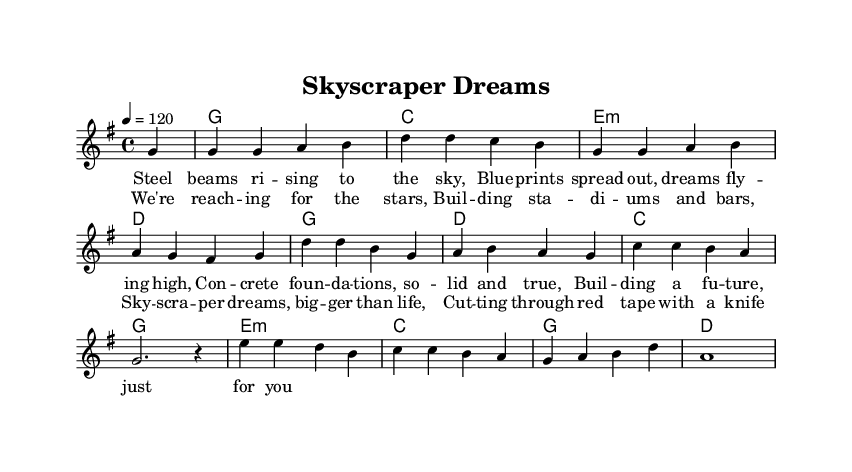What is the key signature of this music? The key signature is G major, which has one sharp (F#). This can be determined by identifying the key indicated in the global section of the code.
Answer: G major What is the time signature of this music? The time signature is 4/4, which means there are four beats in each measure, and the quarter note gets one beat. This can be found in the global section of the code.
Answer: 4/4 What is the tempo marking for this piece? The tempo marking is 120 beats per minute. This is specified in the global section of the code with the tempo command.
Answer: 120 How many measures are in the melody? The melody consists of 8 measures, which can be counted by dividing the notes and rests presented in the melody section into separate measures.
Answer: 8 What is the name of the anthem? The name of the anthem is "Skyscraper Dreams," indicated in the header section of the code.
Answer: Skyscraper Dreams How do the lyrics reflect the theme of ambition? The lyrics emphasize ambition through phrases like "reach for the stars" and "building a future," which convey a sense of striving and achievement. Analyzing the specific lyrics reveals this theme is prevalent in both the verses and chorus.
Answer: Ambition What chord is used most frequently in the harmony section? The chord used most frequently is G major, as seen in the harmonies section where it appears multiple times. By counting the occurrences, it stands out as the dominant chord in this piece.
Answer: G 